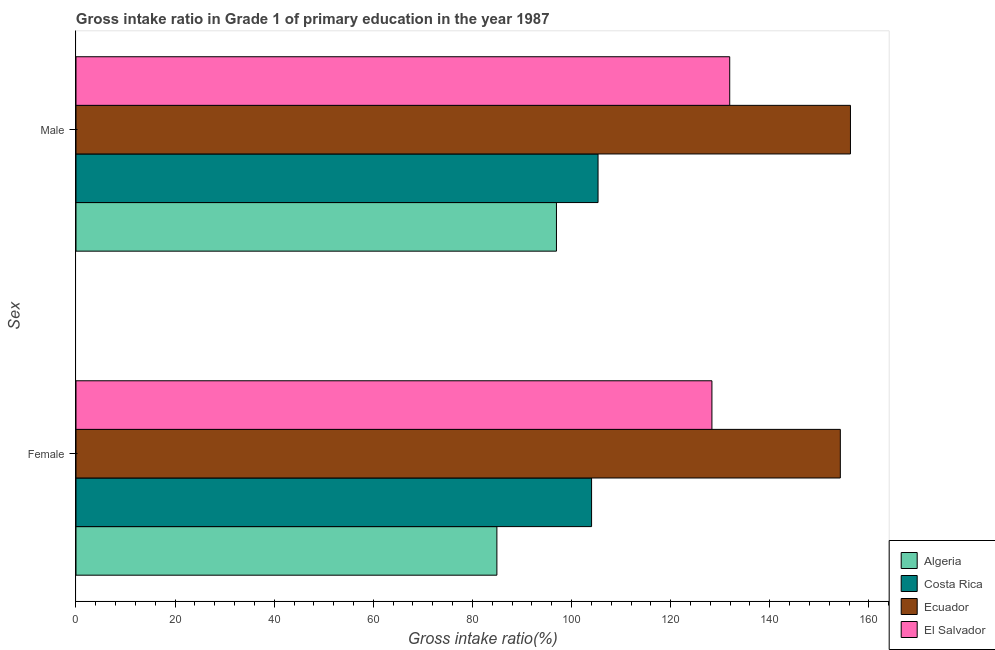How many groups of bars are there?
Keep it short and to the point. 2. Are the number of bars per tick equal to the number of legend labels?
Offer a terse response. Yes. Are the number of bars on each tick of the Y-axis equal?
Ensure brevity in your answer.  Yes. How many bars are there on the 1st tick from the top?
Offer a terse response. 4. What is the label of the 1st group of bars from the top?
Provide a short and direct response. Male. What is the gross intake ratio(male) in Algeria?
Ensure brevity in your answer.  96.96. Across all countries, what is the maximum gross intake ratio(male)?
Provide a succinct answer. 156.29. Across all countries, what is the minimum gross intake ratio(female)?
Your answer should be very brief. 84.94. In which country was the gross intake ratio(male) maximum?
Keep it short and to the point. Ecuador. In which country was the gross intake ratio(female) minimum?
Provide a succinct answer. Algeria. What is the total gross intake ratio(female) in the graph?
Keep it short and to the point. 471.56. What is the difference between the gross intake ratio(female) in Costa Rica and that in Algeria?
Make the answer very short. 19.11. What is the difference between the gross intake ratio(female) in Costa Rica and the gross intake ratio(male) in Algeria?
Offer a very short reply. 7.09. What is the average gross intake ratio(female) per country?
Your response must be concise. 117.89. What is the difference between the gross intake ratio(female) and gross intake ratio(male) in El Salvador?
Offer a very short reply. -3.59. What is the ratio of the gross intake ratio(female) in Algeria to that in Costa Rica?
Your answer should be very brief. 0.82. Is the gross intake ratio(male) in El Salvador less than that in Costa Rica?
Give a very brief answer. No. What does the 4th bar from the top in Male represents?
Your answer should be very brief. Algeria. How many countries are there in the graph?
Offer a terse response. 4. What is the difference between two consecutive major ticks on the X-axis?
Offer a terse response. 20. Does the graph contain grids?
Ensure brevity in your answer.  No. Where does the legend appear in the graph?
Your answer should be very brief. Bottom right. How many legend labels are there?
Your answer should be compact. 4. What is the title of the graph?
Give a very brief answer. Gross intake ratio in Grade 1 of primary education in the year 1987. Does "Bulgaria" appear as one of the legend labels in the graph?
Offer a very short reply. No. What is the label or title of the X-axis?
Your answer should be very brief. Gross intake ratio(%). What is the label or title of the Y-axis?
Offer a very short reply. Sex. What is the Gross intake ratio(%) in Algeria in Female?
Give a very brief answer. 84.94. What is the Gross intake ratio(%) in Costa Rica in Female?
Make the answer very short. 104.04. What is the Gross intake ratio(%) in Ecuador in Female?
Keep it short and to the point. 154.24. What is the Gross intake ratio(%) of El Salvador in Female?
Your answer should be compact. 128.33. What is the Gross intake ratio(%) of Algeria in Male?
Offer a terse response. 96.96. What is the Gross intake ratio(%) in Costa Rica in Male?
Offer a terse response. 105.35. What is the Gross intake ratio(%) in Ecuador in Male?
Make the answer very short. 156.29. What is the Gross intake ratio(%) in El Salvador in Male?
Your answer should be compact. 131.92. Across all Sex, what is the maximum Gross intake ratio(%) of Algeria?
Provide a succinct answer. 96.96. Across all Sex, what is the maximum Gross intake ratio(%) in Costa Rica?
Offer a terse response. 105.35. Across all Sex, what is the maximum Gross intake ratio(%) of Ecuador?
Provide a short and direct response. 156.29. Across all Sex, what is the maximum Gross intake ratio(%) in El Salvador?
Your response must be concise. 131.92. Across all Sex, what is the minimum Gross intake ratio(%) in Algeria?
Offer a very short reply. 84.94. Across all Sex, what is the minimum Gross intake ratio(%) in Costa Rica?
Give a very brief answer. 104.04. Across all Sex, what is the minimum Gross intake ratio(%) in Ecuador?
Offer a terse response. 154.24. Across all Sex, what is the minimum Gross intake ratio(%) in El Salvador?
Offer a very short reply. 128.33. What is the total Gross intake ratio(%) in Algeria in the graph?
Provide a succinct answer. 181.9. What is the total Gross intake ratio(%) of Costa Rica in the graph?
Your answer should be compact. 209.4. What is the total Gross intake ratio(%) of Ecuador in the graph?
Your response must be concise. 310.53. What is the total Gross intake ratio(%) in El Salvador in the graph?
Make the answer very short. 260.25. What is the difference between the Gross intake ratio(%) of Algeria in Female and that in Male?
Offer a terse response. -12.02. What is the difference between the Gross intake ratio(%) in Costa Rica in Female and that in Male?
Your response must be concise. -1.31. What is the difference between the Gross intake ratio(%) of Ecuador in Female and that in Male?
Your response must be concise. -2.04. What is the difference between the Gross intake ratio(%) in El Salvador in Female and that in Male?
Make the answer very short. -3.59. What is the difference between the Gross intake ratio(%) of Algeria in Female and the Gross intake ratio(%) of Costa Rica in Male?
Provide a short and direct response. -20.42. What is the difference between the Gross intake ratio(%) of Algeria in Female and the Gross intake ratio(%) of Ecuador in Male?
Provide a succinct answer. -71.35. What is the difference between the Gross intake ratio(%) of Algeria in Female and the Gross intake ratio(%) of El Salvador in Male?
Your answer should be very brief. -46.99. What is the difference between the Gross intake ratio(%) in Costa Rica in Female and the Gross intake ratio(%) in Ecuador in Male?
Ensure brevity in your answer.  -52.24. What is the difference between the Gross intake ratio(%) of Costa Rica in Female and the Gross intake ratio(%) of El Salvador in Male?
Offer a very short reply. -27.88. What is the difference between the Gross intake ratio(%) in Ecuador in Female and the Gross intake ratio(%) in El Salvador in Male?
Offer a very short reply. 22.32. What is the average Gross intake ratio(%) in Algeria per Sex?
Offer a very short reply. 90.95. What is the average Gross intake ratio(%) of Costa Rica per Sex?
Offer a terse response. 104.7. What is the average Gross intake ratio(%) in Ecuador per Sex?
Give a very brief answer. 155.27. What is the average Gross intake ratio(%) in El Salvador per Sex?
Your response must be concise. 130.13. What is the difference between the Gross intake ratio(%) in Algeria and Gross intake ratio(%) in Costa Rica in Female?
Your answer should be compact. -19.11. What is the difference between the Gross intake ratio(%) of Algeria and Gross intake ratio(%) of Ecuador in Female?
Provide a short and direct response. -69.31. What is the difference between the Gross intake ratio(%) in Algeria and Gross intake ratio(%) in El Salvador in Female?
Make the answer very short. -43.39. What is the difference between the Gross intake ratio(%) in Costa Rica and Gross intake ratio(%) in Ecuador in Female?
Provide a succinct answer. -50.2. What is the difference between the Gross intake ratio(%) in Costa Rica and Gross intake ratio(%) in El Salvador in Female?
Provide a succinct answer. -24.29. What is the difference between the Gross intake ratio(%) in Ecuador and Gross intake ratio(%) in El Salvador in Female?
Make the answer very short. 25.91. What is the difference between the Gross intake ratio(%) in Algeria and Gross intake ratio(%) in Costa Rica in Male?
Give a very brief answer. -8.39. What is the difference between the Gross intake ratio(%) in Algeria and Gross intake ratio(%) in Ecuador in Male?
Provide a succinct answer. -59.33. What is the difference between the Gross intake ratio(%) in Algeria and Gross intake ratio(%) in El Salvador in Male?
Offer a terse response. -34.96. What is the difference between the Gross intake ratio(%) of Costa Rica and Gross intake ratio(%) of Ecuador in Male?
Offer a terse response. -50.94. What is the difference between the Gross intake ratio(%) in Costa Rica and Gross intake ratio(%) in El Salvador in Male?
Make the answer very short. -26.57. What is the difference between the Gross intake ratio(%) of Ecuador and Gross intake ratio(%) of El Salvador in Male?
Give a very brief answer. 24.37. What is the ratio of the Gross intake ratio(%) in Algeria in Female to that in Male?
Offer a very short reply. 0.88. What is the ratio of the Gross intake ratio(%) in Costa Rica in Female to that in Male?
Provide a succinct answer. 0.99. What is the ratio of the Gross intake ratio(%) in Ecuador in Female to that in Male?
Keep it short and to the point. 0.99. What is the ratio of the Gross intake ratio(%) of El Salvador in Female to that in Male?
Ensure brevity in your answer.  0.97. What is the difference between the highest and the second highest Gross intake ratio(%) of Algeria?
Provide a short and direct response. 12.02. What is the difference between the highest and the second highest Gross intake ratio(%) in Costa Rica?
Give a very brief answer. 1.31. What is the difference between the highest and the second highest Gross intake ratio(%) of Ecuador?
Your answer should be compact. 2.04. What is the difference between the highest and the second highest Gross intake ratio(%) in El Salvador?
Provide a short and direct response. 3.59. What is the difference between the highest and the lowest Gross intake ratio(%) in Algeria?
Your response must be concise. 12.02. What is the difference between the highest and the lowest Gross intake ratio(%) of Costa Rica?
Make the answer very short. 1.31. What is the difference between the highest and the lowest Gross intake ratio(%) of Ecuador?
Ensure brevity in your answer.  2.04. What is the difference between the highest and the lowest Gross intake ratio(%) of El Salvador?
Ensure brevity in your answer.  3.59. 